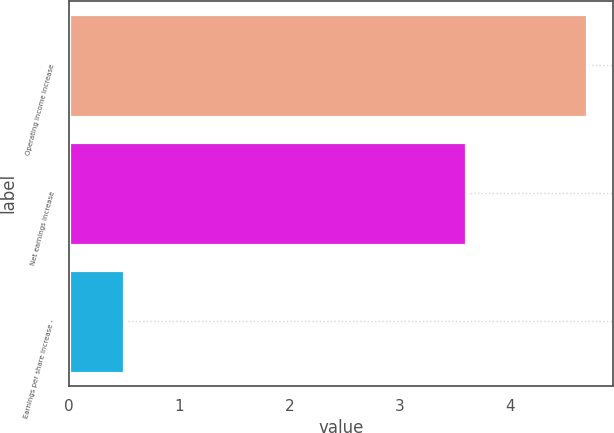Convert chart to OTSL. <chart><loc_0><loc_0><loc_500><loc_500><bar_chart><fcel>Operating income increase<fcel>Net earnings increase<fcel>Earnings per share increase -<nl><fcel>4.7<fcel>3.6<fcel>0.5<nl></chart> 